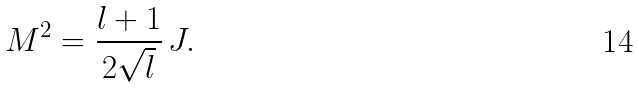<formula> <loc_0><loc_0><loc_500><loc_500>M ^ { 2 } = \frac { l + 1 } { 2 \sqrt { l } } \, J .</formula> 